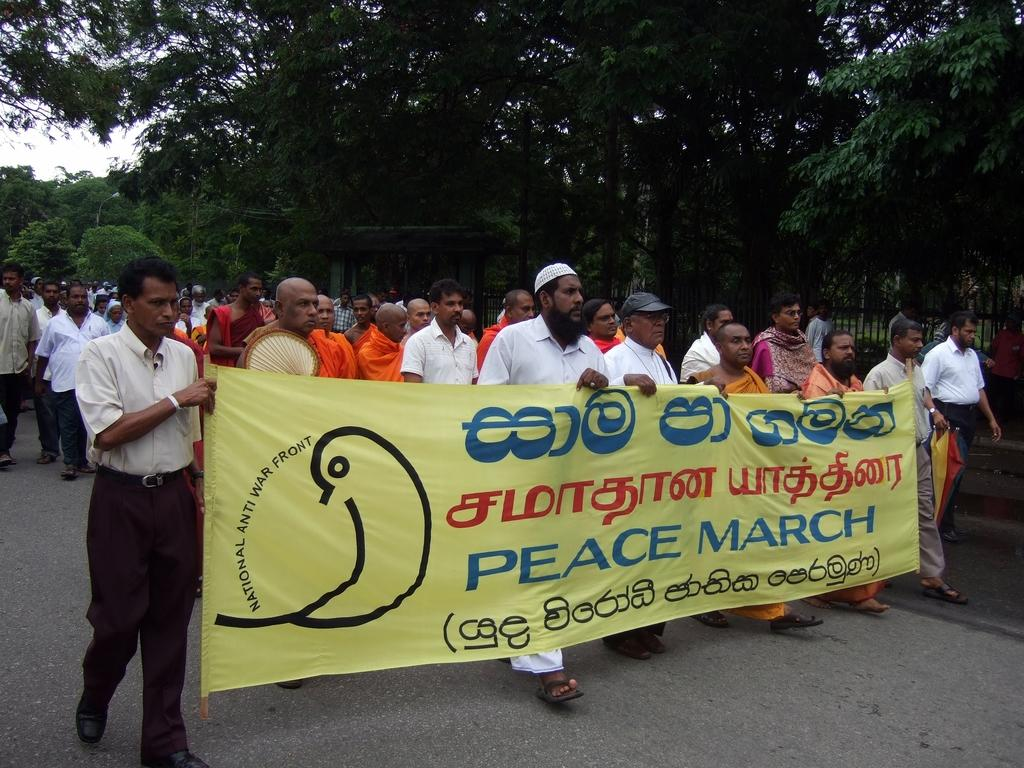What is happening on the road in the image? There is a group of people on the road in the image. What are some of the people doing in the image? Some of the people are holding a banner in the image. What can be seen in the background of the image? There are trees, a fence, and the sky visible in the background of the image. What type of notebook is being used by the people holding the banner in the image? There is no notebook present in the image; the people holding the banner are not using any notebooks. 